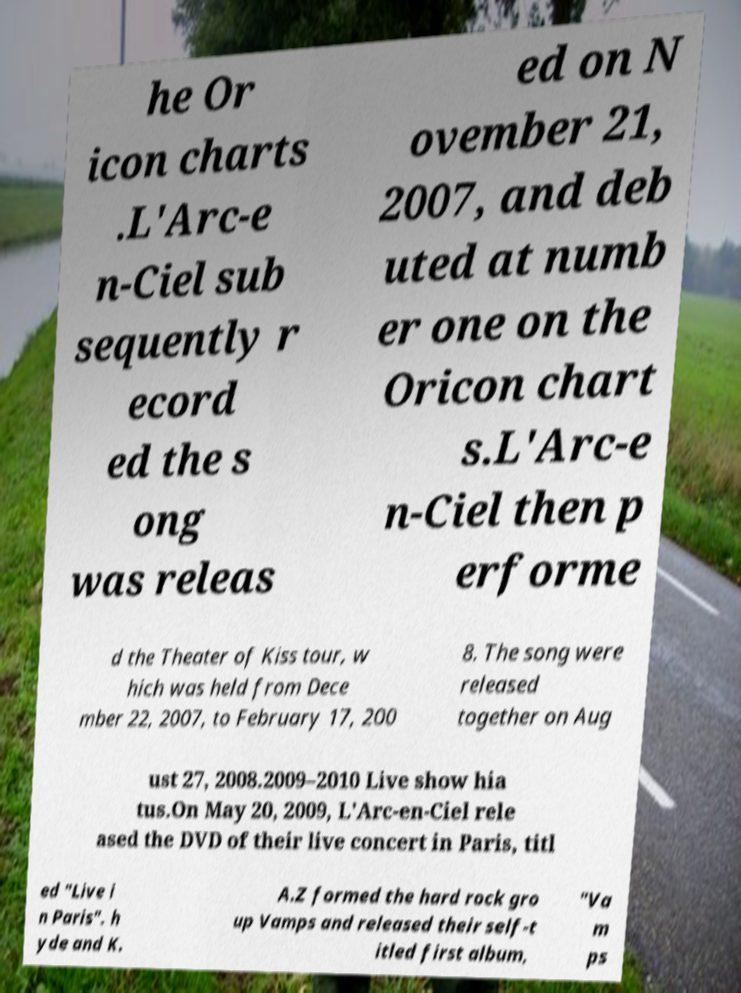Could you extract and type out the text from this image? he Or icon charts .L'Arc-e n-Ciel sub sequently r ecord ed the s ong was releas ed on N ovember 21, 2007, and deb uted at numb er one on the Oricon chart s.L'Arc-e n-Ciel then p erforme d the Theater of Kiss tour, w hich was held from Dece mber 22, 2007, to February 17, 200 8. The song were released together on Aug ust 27, 2008.2009–2010 Live show hia tus.On May 20, 2009, L'Arc-en-Ciel rele ased the DVD of their live concert in Paris, titl ed "Live i n Paris". h yde and K. A.Z formed the hard rock gro up Vamps and released their self-t itled first album, "Va m ps 